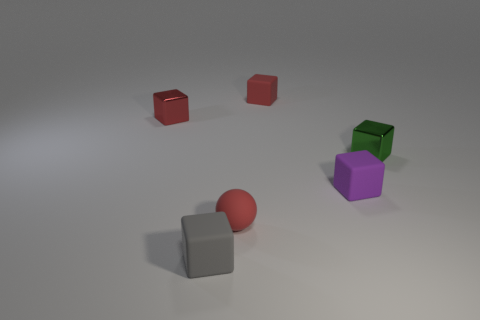Is there a pattern to how the objects are arranged? There doesn't seem to be a discernible pattern to the arrangement of objects. They are placed at seemingly random positions within the field of view, without a clear sequence or symmetry in their arrangement. 